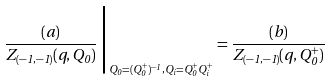Convert formula to latex. <formula><loc_0><loc_0><loc_500><loc_500>\frac { ( a ) } { Z _ { ( - 1 , - 1 ) } ( q , Q _ { 0 } ) } \, \Big | _ { Q _ { 0 } = ( Q _ { 0 } ^ { + } ) ^ { - 1 } , Q _ { i } = Q _ { 0 } ^ { + } Q _ { i } ^ { + } } = \frac { ( b ) } { Z _ { ( - 1 , - 1 ) } ( q , Q _ { 0 } ^ { + } ) }</formula> 